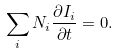<formula> <loc_0><loc_0><loc_500><loc_500>\sum _ { i } N _ { i } \frac { \partial I _ { i } } { \partial t } = 0 .</formula> 